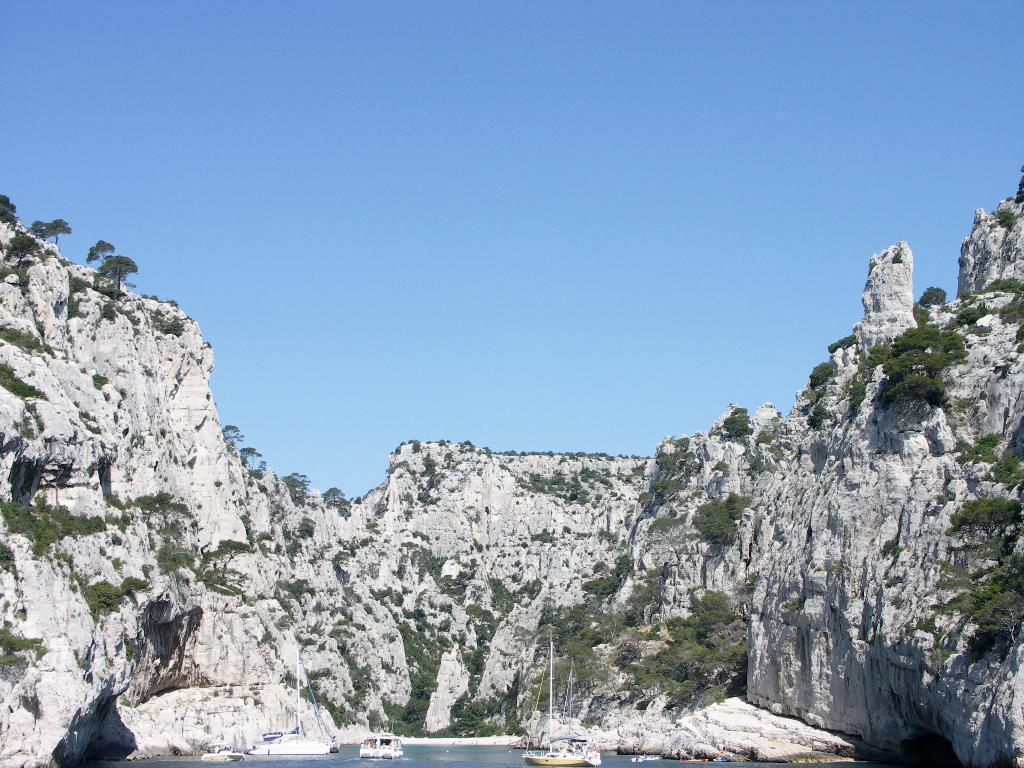What is the main subject of the image? The main subject of the image is ships on the water. What else can be seen in the image besides the ships? There is a rock mountain with plants on it in the image. How would you describe the sky in the image? The sky is clear in the image. Can you tell me how many times the heart beats in the image? There is no heart present in the image, so it is not possible to determine how many times it beats. 